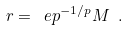<formula> <loc_0><loc_0><loc_500><loc_500>r = \ e p ^ { - 1 / p } M \ .</formula> 